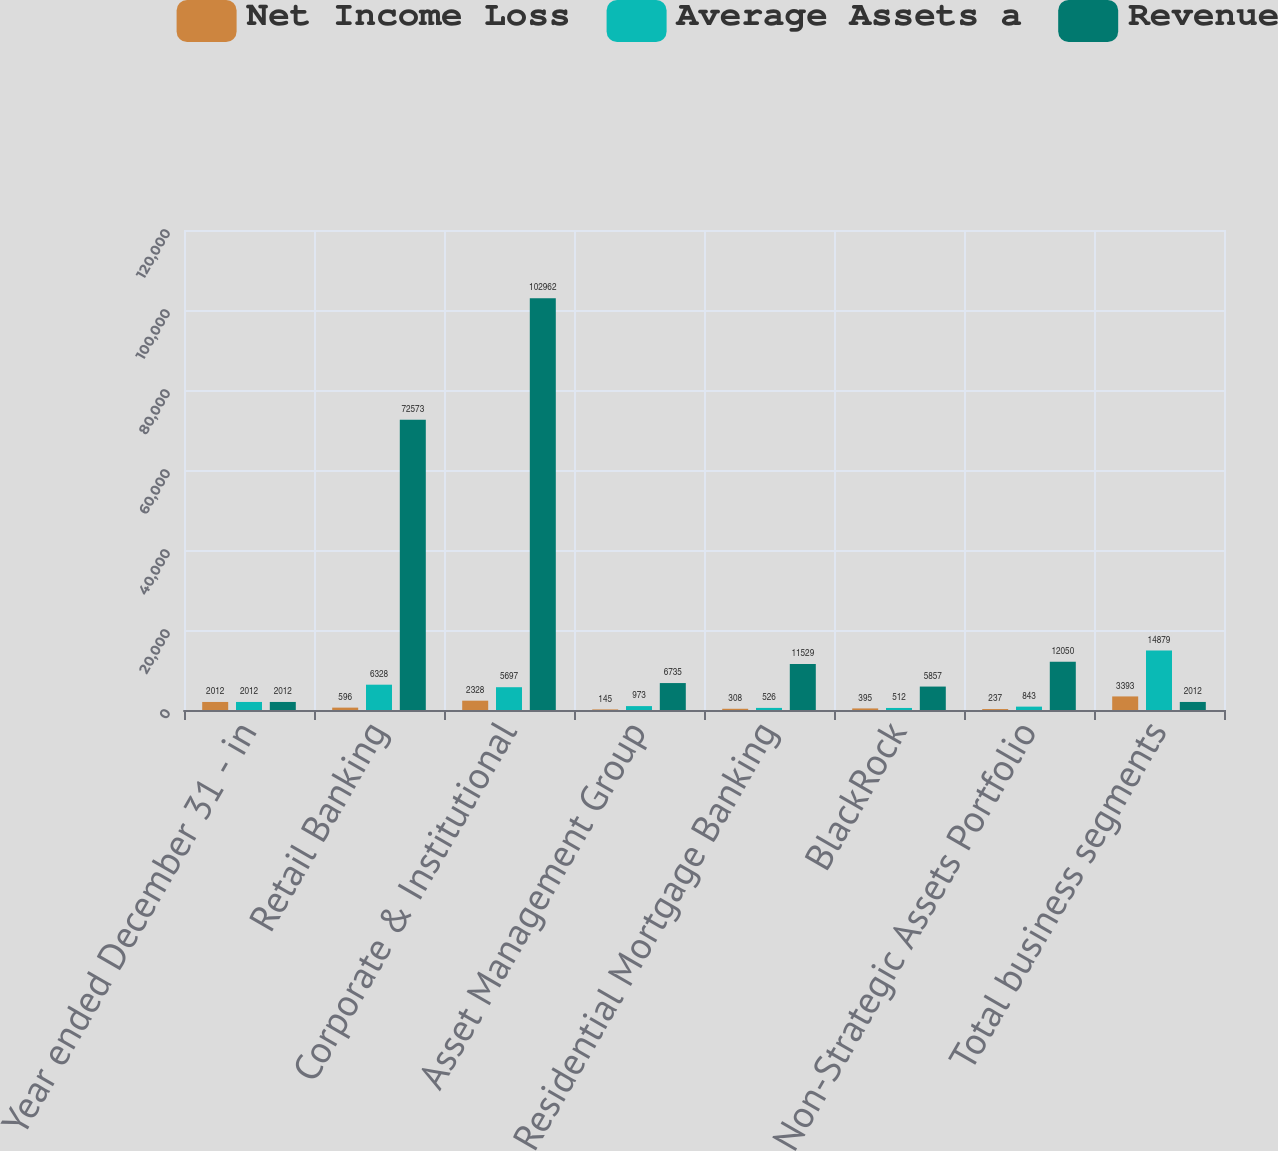<chart> <loc_0><loc_0><loc_500><loc_500><stacked_bar_chart><ecel><fcel>Year ended December 31 - in<fcel>Retail Banking<fcel>Corporate & Institutional<fcel>Asset Management Group<fcel>Residential Mortgage Banking<fcel>BlackRock<fcel>Non-Strategic Assets Portfolio<fcel>Total business segments<nl><fcel>Net Income Loss<fcel>2012<fcel>596<fcel>2328<fcel>145<fcel>308<fcel>395<fcel>237<fcel>3393<nl><fcel>Average Assets a<fcel>2012<fcel>6328<fcel>5697<fcel>973<fcel>526<fcel>512<fcel>843<fcel>14879<nl><fcel>Revenue<fcel>2012<fcel>72573<fcel>102962<fcel>6735<fcel>11529<fcel>5857<fcel>12050<fcel>2012<nl></chart> 